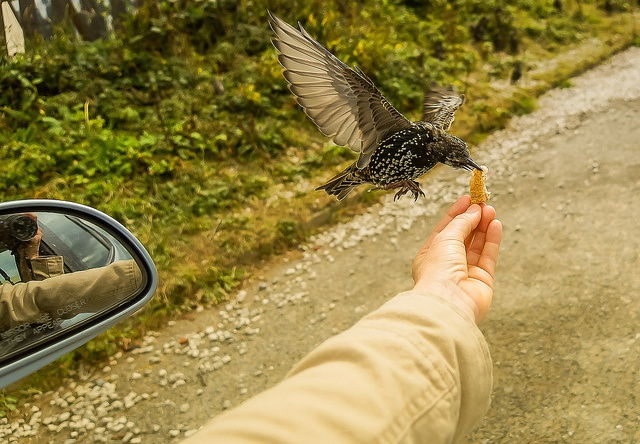Describe the objects in this image and their specific colors. I can see people in olive, tan, and beige tones, car in olive, black, gray, and darkgray tones, and bird in olive, black, and tan tones in this image. 